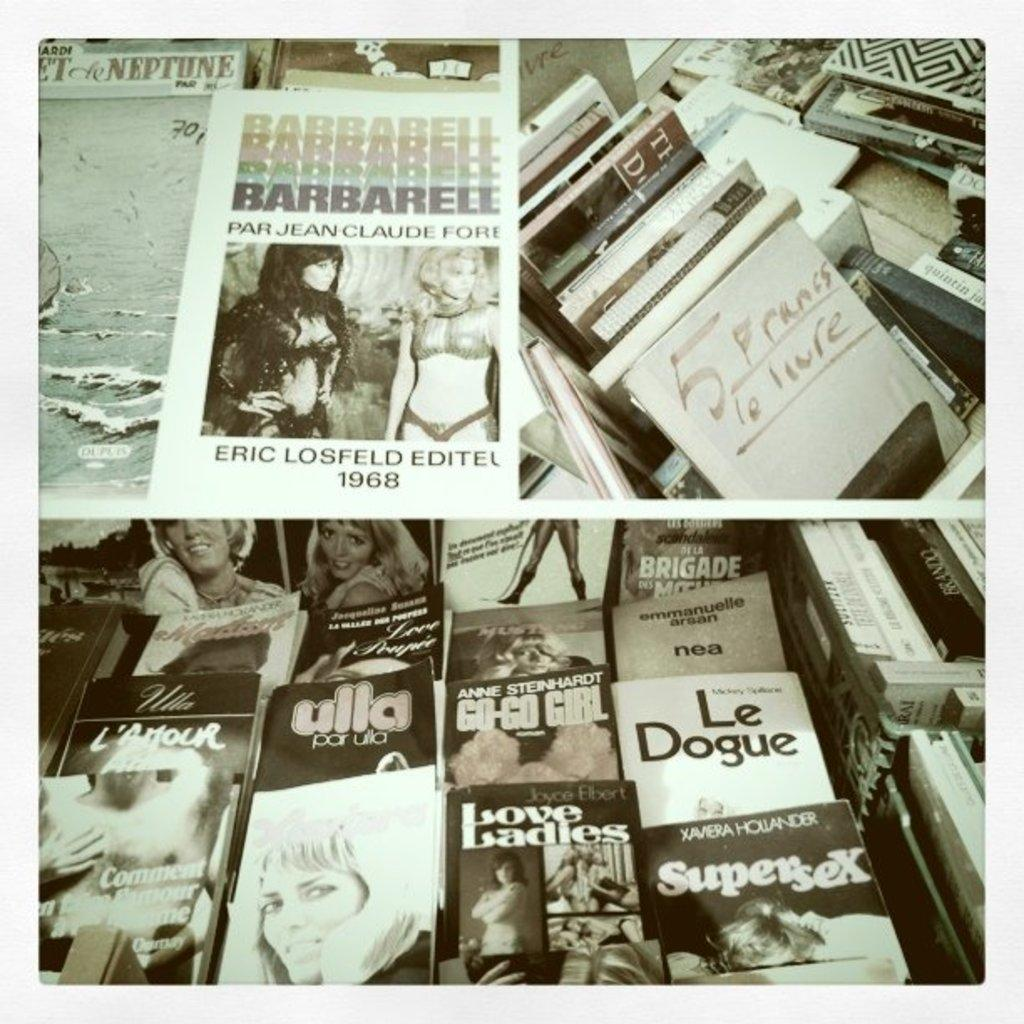What type of objects can be seen in the image? There are books in the image. Can you describe the books in more detail? The books have pictures along with text. What type of sound can be heard coming from the books in the image? There is no sound coming from the books in the image, as they are inanimate objects. 